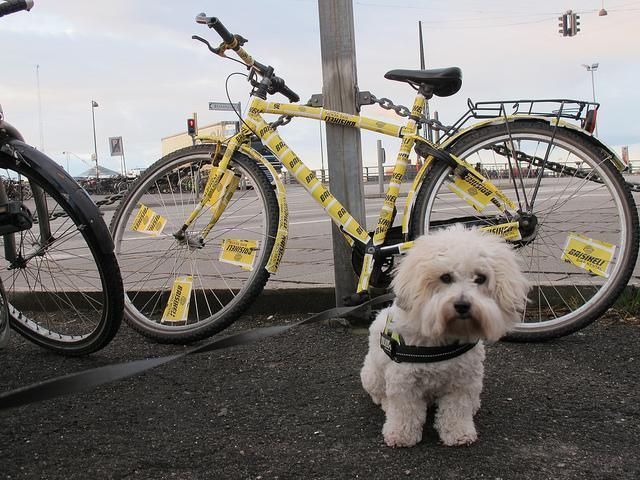How many bikes are in the picture?
Give a very brief answer. 2. How many bicycles are there?
Give a very brief answer. 2. 